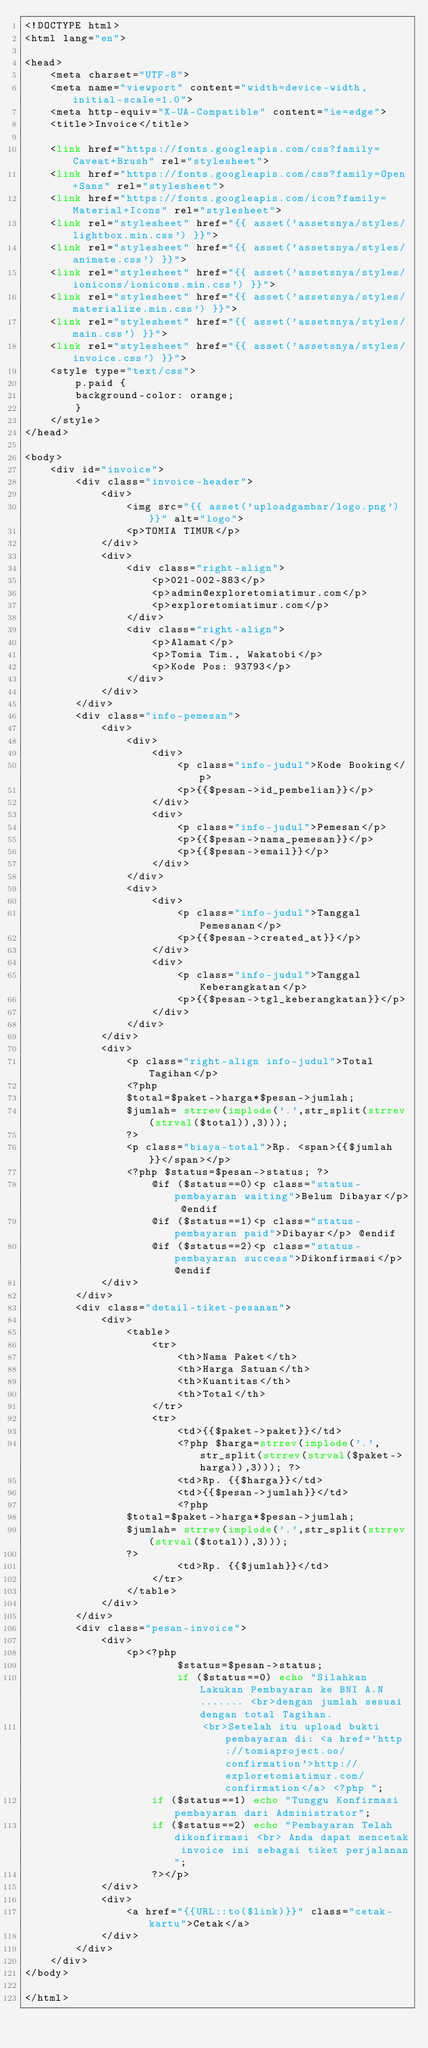<code> <loc_0><loc_0><loc_500><loc_500><_PHP_><!DOCTYPE html>
<html lang="en">

<head>
    <meta charset="UTF-8">
    <meta name="viewport" content="width=device-width, initial-scale=1.0">
    <meta http-equiv="X-UA-Compatible" content="ie=edge">
    <title>Invoice</title>

    <link href="https://fonts.googleapis.com/css?family=Caveat+Brush" rel="stylesheet">
    <link href="https://fonts.googleapis.com/css?family=Open+Sans" rel="stylesheet">
    <link href="https://fonts.googleapis.com/icon?family=Material+Icons" rel="stylesheet">
    <link rel="stylesheet" href="{{ asset('assetsnya/styles/lightbox.min.css') }}">
    <link rel="stylesheet" href="{{ asset('assetsnya/styles/animate.css') }}">
    <link rel="stylesheet" href="{{ asset('assetsnya/styles/ionicons/ionicons.min.css') }}">
    <link rel="stylesheet" href="{{ asset('assetsnya/styles/materialize.min.css') }}">
    <link rel="stylesheet" href="{{ asset('assetsnya/styles/main.css') }}">
    <link rel="stylesheet" href="{{ asset('assetsnya/styles/invoice.css') }}">
    <style type="text/css">
        p.paid {
        background-color: orange;
        }
    </style>
</head>

<body>
    <div id="invoice">
        <div class="invoice-header">
            <div>
                <img src="{{ asset('uploadgambar/logo.png') }}" alt="logo">
                <p>TOMIA TIMUR</p>
            </div>
            <div>
                <div class="right-align">
                    <p>021-002-883</p>
                    <p>admin@exploretomiatimur.com</p>
                    <p>exploretomiatimur.com</p>
                </div>
                <div class="right-align">
                    <p>Alamat</p>
                    <p>Tomia Tim., Wakatobi</p>
                    <p>Kode Pos: 93793</p>
                </div>
            </div>
        </div>
        <div class="info-pemesan">
            <div>
                <div>
                    <div>
                        <p class="info-judul">Kode Booking</p>
                        <p>{{$pesan->id_pembelian}}</p>
                    </div>
                    <div>
                        <p class="info-judul">Pemesan</p>
                        <p>{{$pesan->nama_pemesan}}</p>
                        <p>{{$pesan->email}}</p>
                    </div>
                </div>
                <div>
                    <div>
                        <p class="info-judul">Tanggal Pemesanan</p>
                        <p>{{$pesan->created_at}}</p>
                    </div>
                    <div>
                        <p class="info-judul">Tanggal Keberangkatan</p>
                        <p>{{$pesan->tgl_keberangkatan}}</p>
                    </div>
                </div>
            </div>
            <div>
                <p class="right-align info-judul">Total Tagihan</p>
                <?php
                $total=$paket->harga*$pesan->jumlah;
                $jumlah= strrev(implode('.',str_split(strrev(strval($total)),3)));
                ?>
                <p class="biaya-total">Rp. <span>{{$jumlah}}</span></p>
                <?php $status=$pesan->status; ?>
                    @if ($status==0)<p class="status-pembayaran waiting">Belum Dibayar</p> @endif
                    @if ($status==1)<p class="status-pembayaran paid">Dibayar</p> @endif
                    @if ($status==2)<p class="status-pembayaran success">Dikonfirmasi</p> @endif
            </div>
        </div>
        <div class="detail-tiket-pesanan">
            <div>
                <table>
                    <tr>
                        <th>Nama Paket</th>
                        <th>Harga Satuan</th>
                        <th>Kuantitas</th>
                        <th>Total</th>
                    </tr>
                    <tr>
                        <td>{{$paket->paket}}</td>
                        <?php $harga=strrev(implode('.',str_split(strrev(strval($paket->harga)),3))); ?>
                        <td>Rp. {{$harga}}</td>
                        <td>{{$pesan->jumlah}}</td>
                        <?php
                $total=$paket->harga*$pesan->jumlah;
                $jumlah= strrev(implode('.',str_split(strrev(strval($total)),3)));
                ?>
                        <td>Rp. {{$jumlah}}</td>
                    </tr>
                </table>
            </div>
        </div>
        <div class="pesan-invoice">
            <div>
                <p><?php
                        $status=$pesan->status; 
                        if ($status==0) echo "Silahkan Lakukan Pembayaran ke BNI A.N ....... <br>dengan jumlah sesuai dengan total Tagihan.
                            <br>Setelah itu upload bukti pembayaran di: <a href='http://tomiaproject.oo/confirmation'>http://exploretomiatimur.com/confirmation</a> <?php "; 
                    if ($status==1) echo "Tunggu Konfirmasi pembayaran dari Administrator";
                    if ($status==2) echo "Pembayaran Telah dikonfirmasi <br> Anda dapat mencetak invoice ini sebagai tiket perjalanan";
                    ?></p>
            </div>
            <div>
                <a href="{{URL::to($link)}}" class="cetak-kartu">Cetak</a>
            </div>
        </div>
    </div>
</body>

</html></code> 